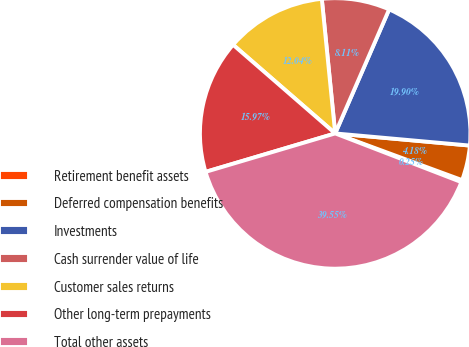Convert chart to OTSL. <chart><loc_0><loc_0><loc_500><loc_500><pie_chart><fcel>Retirement benefit assets<fcel>Deferred compensation benefits<fcel>Investments<fcel>Cash surrender value of life<fcel>Customer sales returns<fcel>Other long-term prepayments<fcel>Total other assets<nl><fcel>0.25%<fcel>4.18%<fcel>19.9%<fcel>8.11%<fcel>12.04%<fcel>15.97%<fcel>39.55%<nl></chart> 